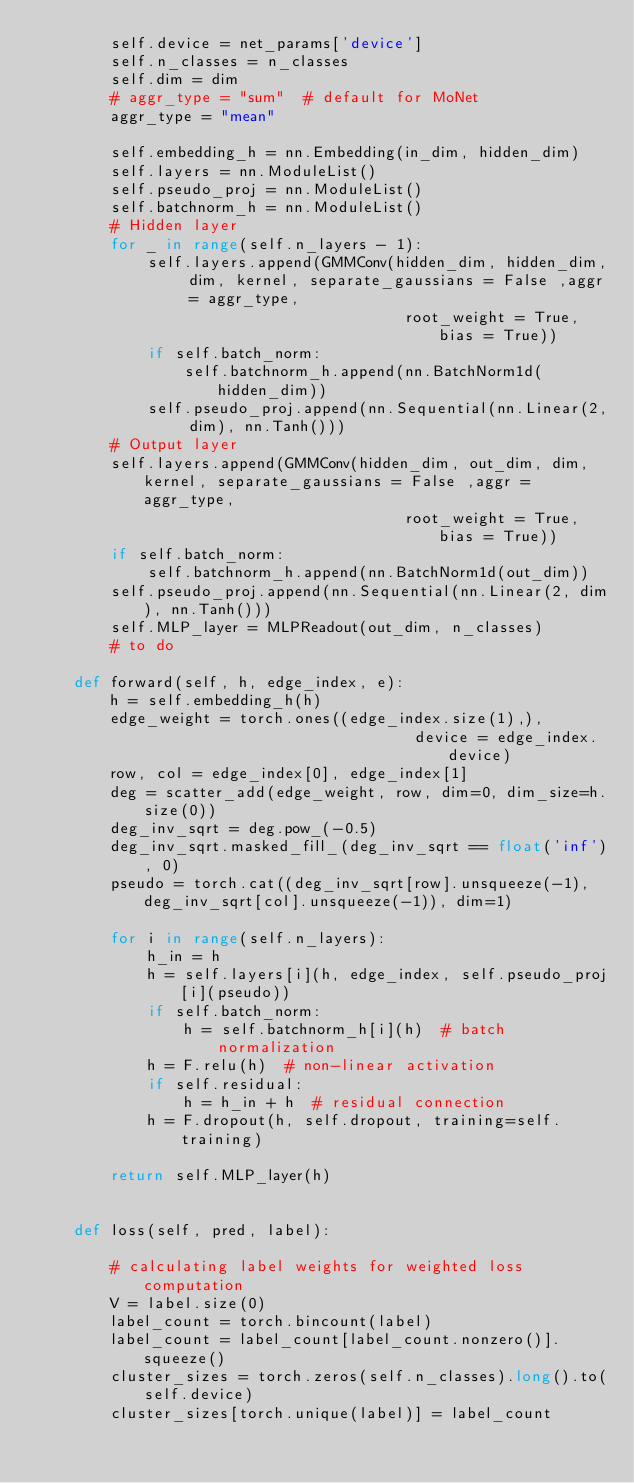<code> <loc_0><loc_0><loc_500><loc_500><_Python_>        self.device = net_params['device']
        self.n_classes = n_classes
        self.dim = dim
        # aggr_type = "sum"  # default for MoNet
        aggr_type = "mean"

        self.embedding_h = nn.Embedding(in_dim, hidden_dim)
        self.layers = nn.ModuleList()
        self.pseudo_proj = nn.ModuleList()
        self.batchnorm_h = nn.ModuleList()
        # Hidden layer
        for _ in range(self.n_layers - 1):
            self.layers.append(GMMConv(hidden_dim, hidden_dim, dim, kernel, separate_gaussians = False ,aggr = aggr_type,
                                        root_weight = True, bias = True))
            if self.batch_norm:
                self.batchnorm_h.append(nn.BatchNorm1d(hidden_dim))
            self.pseudo_proj.append(nn.Sequential(nn.Linear(2, dim), nn.Tanh()))
        # Output layer
        self.layers.append(GMMConv(hidden_dim, out_dim, dim, kernel, separate_gaussians = False ,aggr = aggr_type,
                                        root_weight = True, bias = True))
        if self.batch_norm:
            self.batchnorm_h.append(nn.BatchNorm1d(out_dim))
        self.pseudo_proj.append(nn.Sequential(nn.Linear(2, dim), nn.Tanh()))
        self.MLP_layer = MLPReadout(out_dim, n_classes)
        # to do

    def forward(self, h, edge_index, e):
        h = self.embedding_h(h)
        edge_weight = torch.ones((edge_index.size(1),),
                                         device = edge_index.device)
        row, col = edge_index[0], edge_index[1]
        deg = scatter_add(edge_weight, row, dim=0, dim_size=h.size(0))
        deg_inv_sqrt = deg.pow_(-0.5)
        deg_inv_sqrt.masked_fill_(deg_inv_sqrt == float('inf'), 0)
        pseudo = torch.cat((deg_inv_sqrt[row].unsqueeze(-1), deg_inv_sqrt[col].unsqueeze(-1)), dim=1)

        for i in range(self.n_layers):
            h_in = h
            h = self.layers[i](h, edge_index, self.pseudo_proj[i](pseudo))
            if self.batch_norm:
                h = self.batchnorm_h[i](h)  # batch normalization
            h = F.relu(h)  # non-linear activation
            if self.residual:
                h = h_in + h  # residual connection
            h = F.dropout(h, self.dropout, training=self.training)

        return self.MLP_layer(h)


    def loss(self, pred, label):

        # calculating label weights for weighted loss computation
        V = label.size(0)
        label_count = torch.bincount(label)
        label_count = label_count[label_count.nonzero()].squeeze()
        cluster_sizes = torch.zeros(self.n_classes).long().to(self.device)
        cluster_sizes[torch.unique(label)] = label_count</code> 